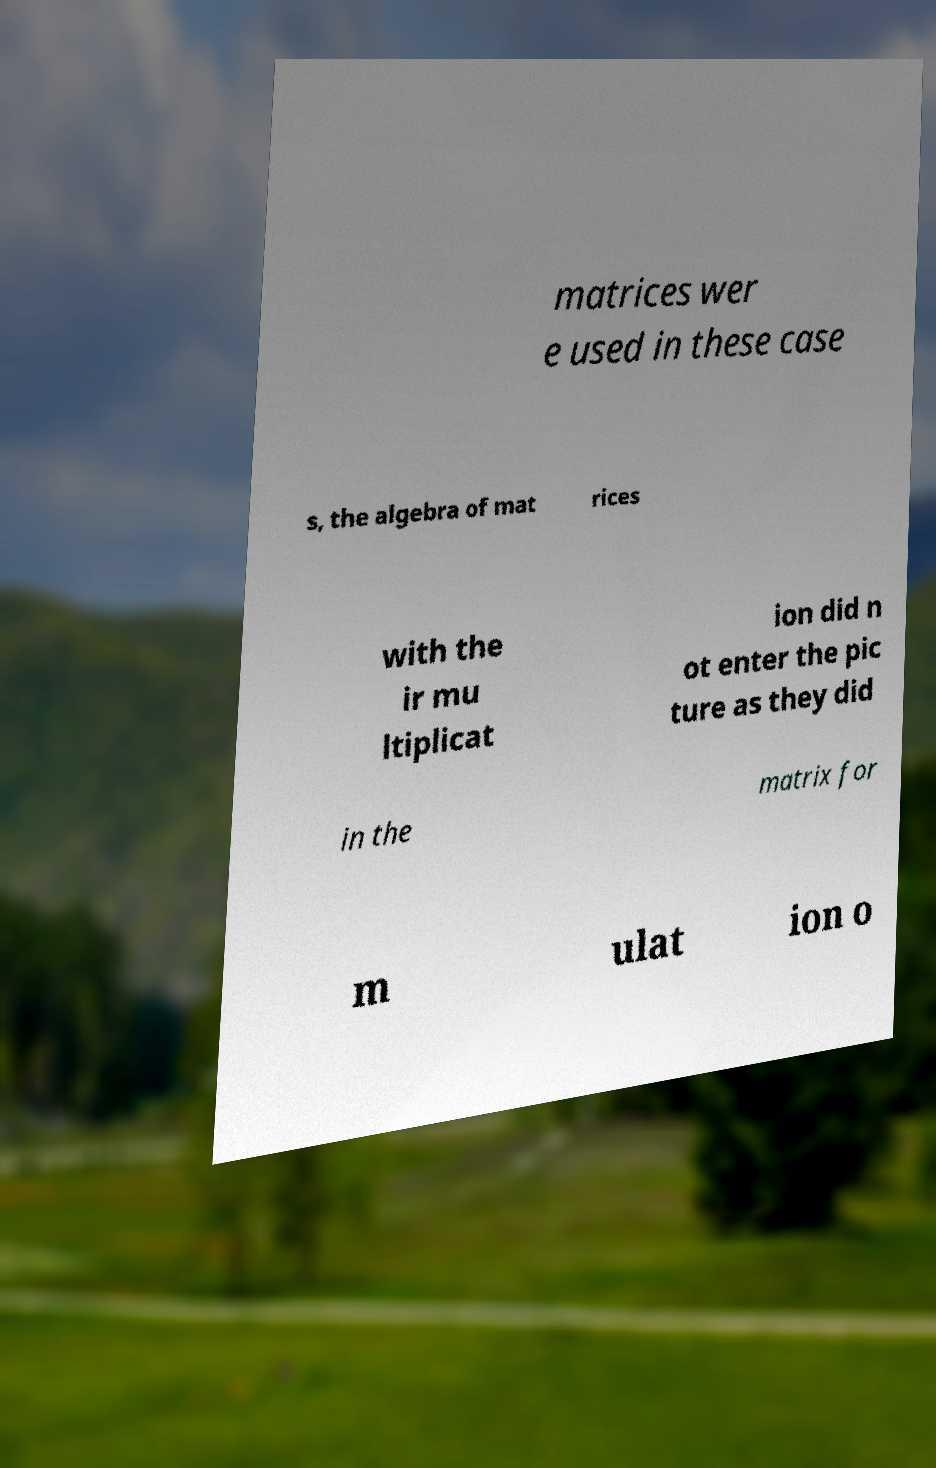There's text embedded in this image that I need extracted. Can you transcribe it verbatim? matrices wer e used in these case s, the algebra of mat rices with the ir mu ltiplicat ion did n ot enter the pic ture as they did in the matrix for m ulat ion o 